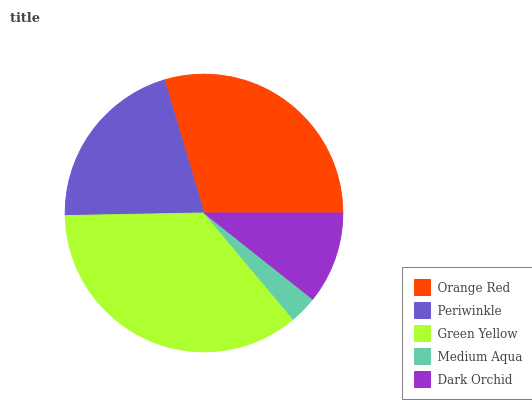Is Medium Aqua the minimum?
Answer yes or no. Yes. Is Green Yellow the maximum?
Answer yes or no. Yes. Is Periwinkle the minimum?
Answer yes or no. No. Is Periwinkle the maximum?
Answer yes or no. No. Is Orange Red greater than Periwinkle?
Answer yes or no. Yes. Is Periwinkle less than Orange Red?
Answer yes or no. Yes. Is Periwinkle greater than Orange Red?
Answer yes or no. No. Is Orange Red less than Periwinkle?
Answer yes or no. No. Is Periwinkle the high median?
Answer yes or no. Yes. Is Periwinkle the low median?
Answer yes or no. Yes. Is Orange Red the high median?
Answer yes or no. No. Is Orange Red the low median?
Answer yes or no. No. 